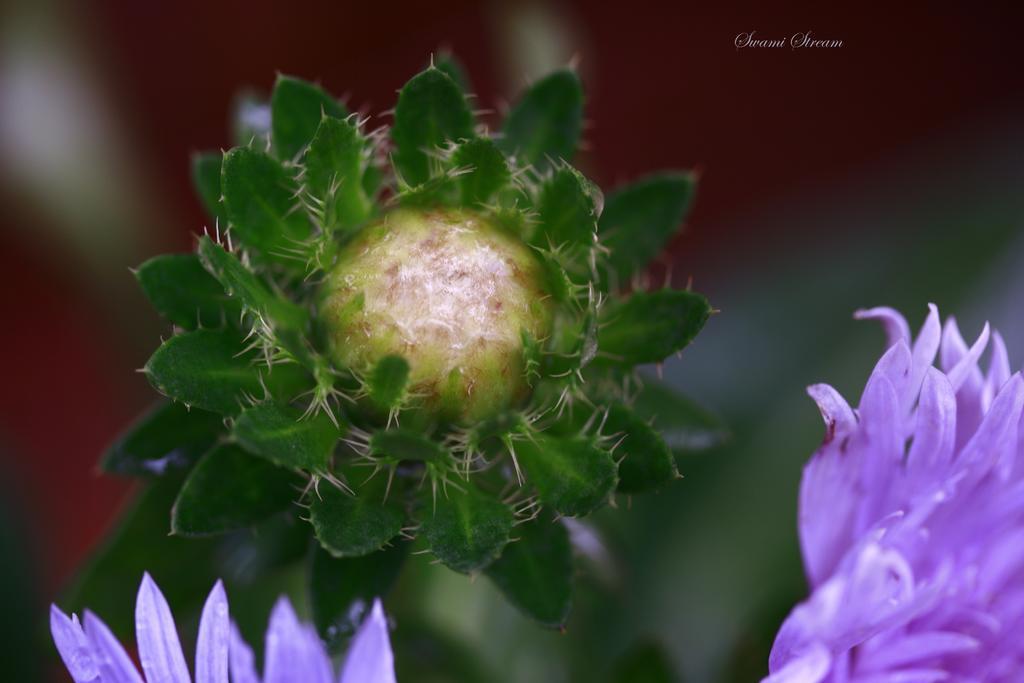In one or two sentences, can you explain what this image depicts? This image consists of flowers which are in the front and the background is blurry. 